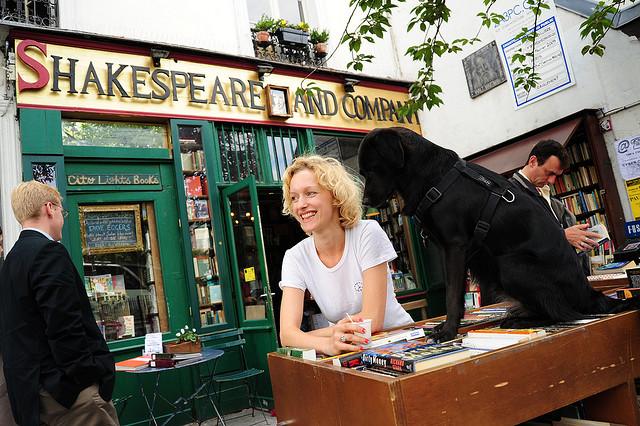What color is the dog?
Answer briefly. Black. What is the store's name?
Quick response, please. Shakespeare and company. What does the sign read?
Keep it brief. Shakespeare and company. Is this a bookstore?
Be succinct. Yes. 